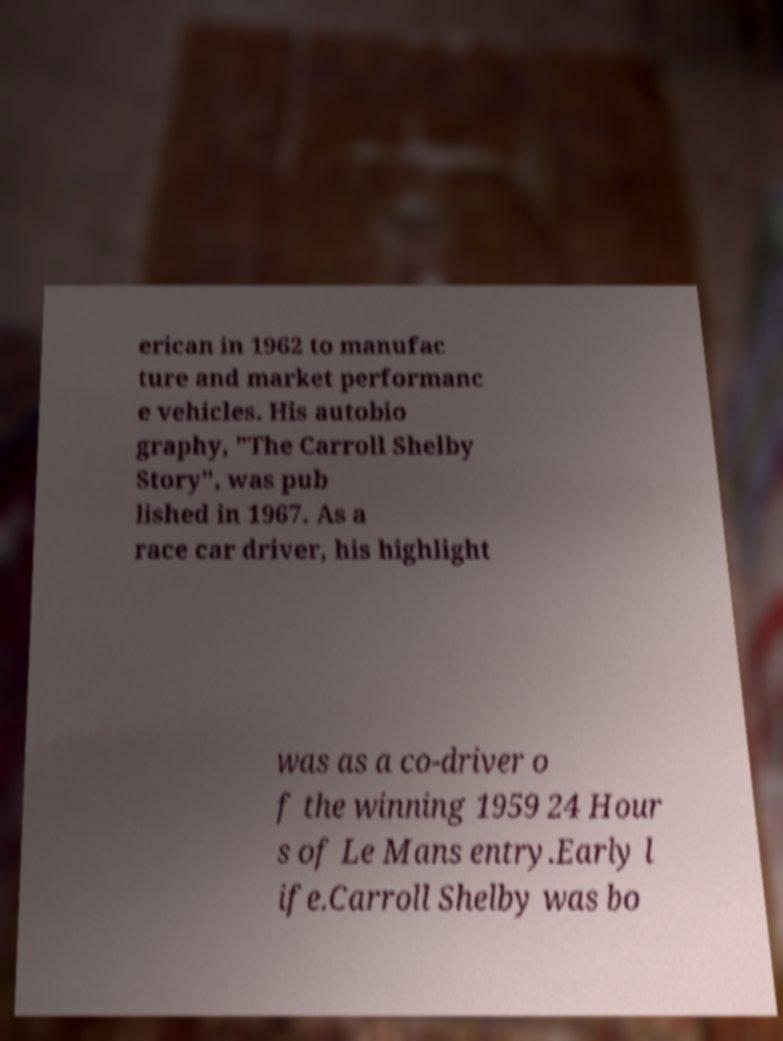Please identify and transcribe the text found in this image. erican in 1962 to manufac ture and market performanc e vehicles. His autobio graphy, "The Carroll Shelby Story", was pub lished in 1967. As a race car driver, his highlight was as a co-driver o f the winning 1959 24 Hour s of Le Mans entry.Early l ife.Carroll Shelby was bo 